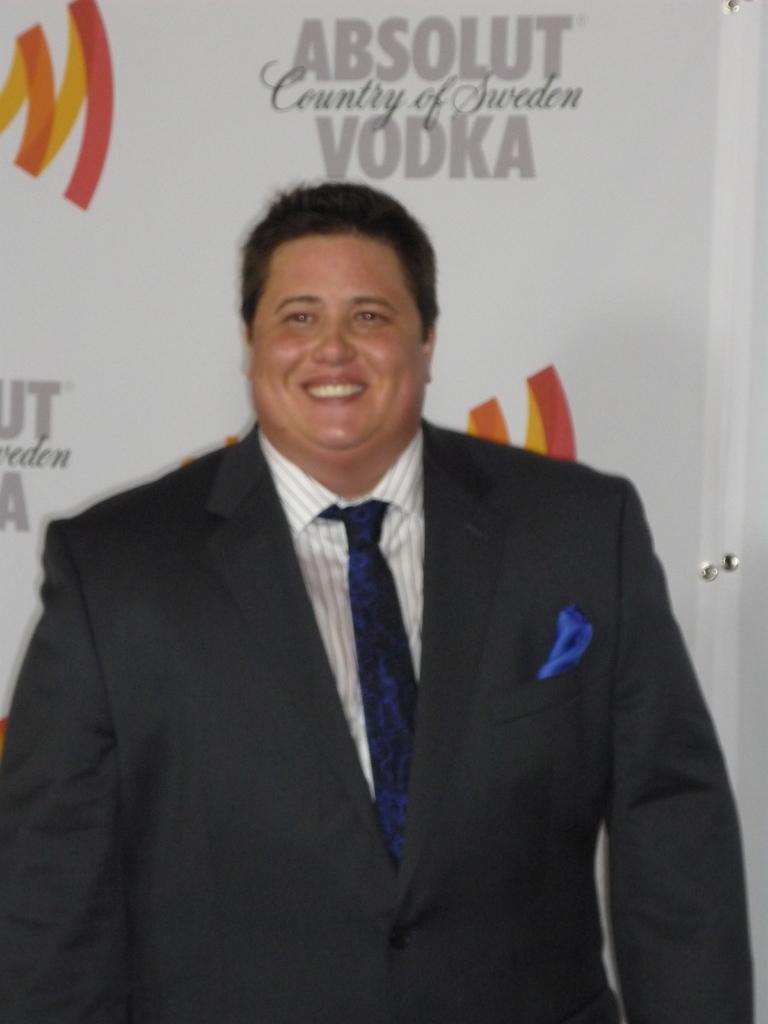In one or two sentences, can you explain what this image depicts? In this picture I can see a man standing wearing a blazer. I can see banner in the background. 